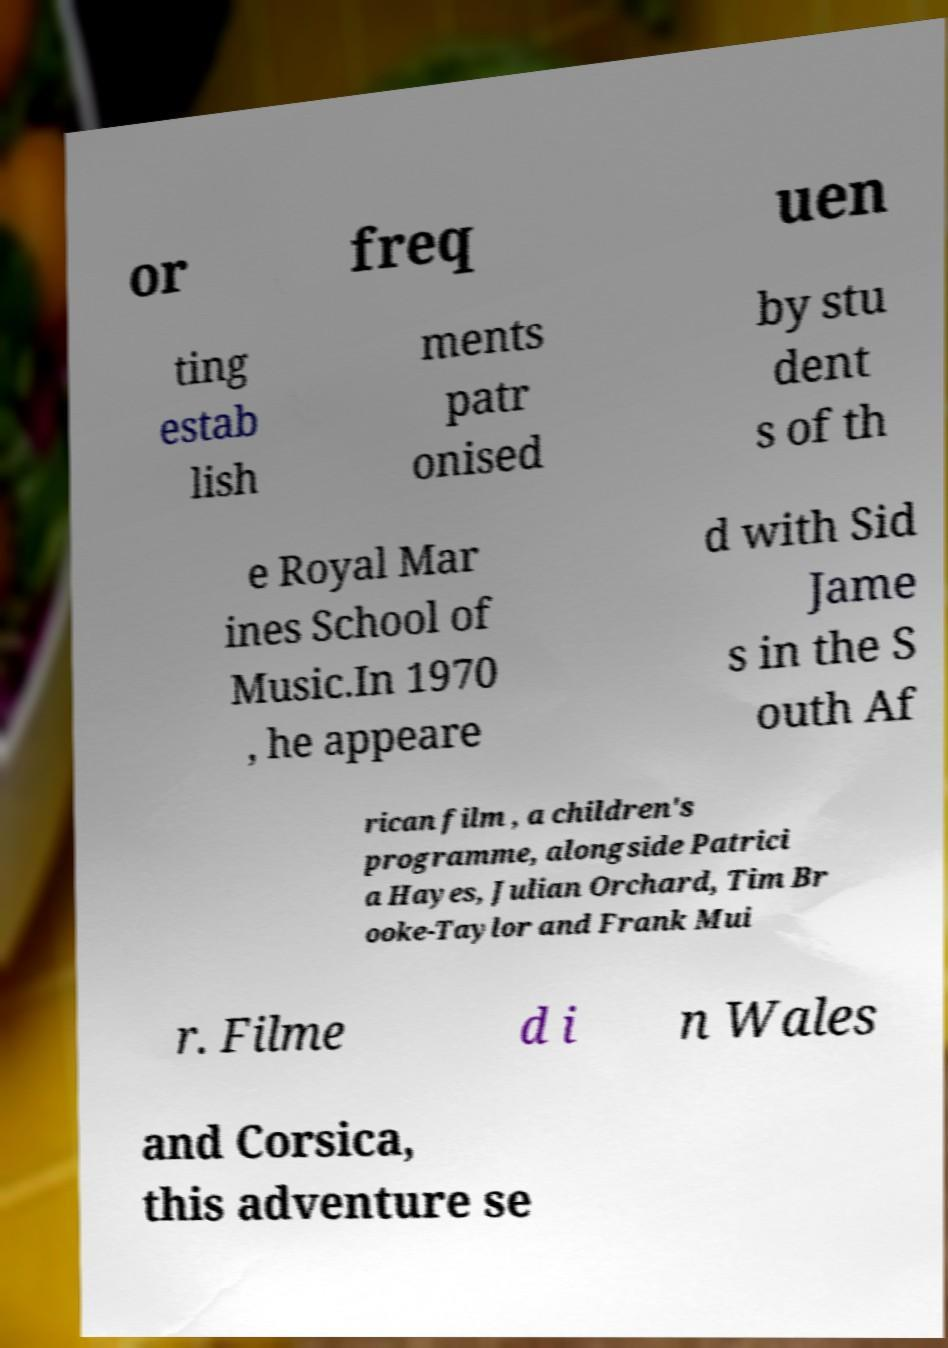Can you accurately transcribe the text from the provided image for me? or freq uen ting estab lish ments patr onised by stu dent s of th e Royal Mar ines School of Music.In 1970 , he appeare d with Sid Jame s in the S outh Af rican film , a children's programme, alongside Patrici a Hayes, Julian Orchard, Tim Br ooke-Taylor and Frank Mui r. Filme d i n Wales and Corsica, this adventure se 